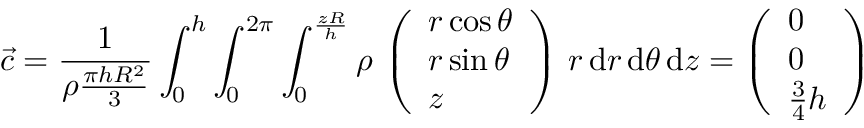<formula> <loc_0><loc_0><loc_500><loc_500>\vec { c } = \frac { 1 } { \rho \frac { \pi h R ^ { 2 } } { 3 } } \int _ { 0 } ^ { h } \int _ { 0 } ^ { 2 \pi } \int _ { 0 } ^ { \frac { z R } { h } } \rho \, \left ( \begin{array} { l } { r \cos \theta } \\ { r \sin \theta } \\ { z } \end{array} \right ) \, r \, d r \, d \theta \, d z = \left ( \begin{array} { l } { 0 } \\ { 0 } \\ { \frac { 3 } { 4 } h } \end{array} \right )</formula> 